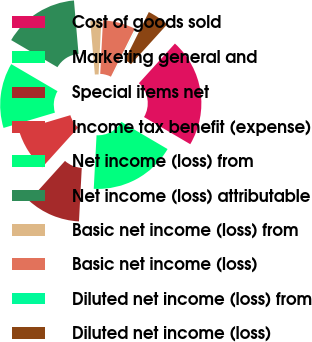<chart> <loc_0><loc_0><loc_500><loc_500><pie_chart><fcel>Cost of goods sold<fcel>Marketing general and<fcel>Special items net<fcel>Income tax benefit (expense)<fcel>Net income (loss) from<fcel>Net income (loss) attributable<fcel>Basic net income (loss) from<fcel>Basic net income (loss)<fcel>Diluted net income (loss) from<fcel>Diluted net income (loss)<nl><fcel>21.72%<fcel>17.38%<fcel>10.87%<fcel>8.7%<fcel>13.04%<fcel>15.21%<fcel>2.19%<fcel>6.53%<fcel>0.02%<fcel>4.36%<nl></chart> 